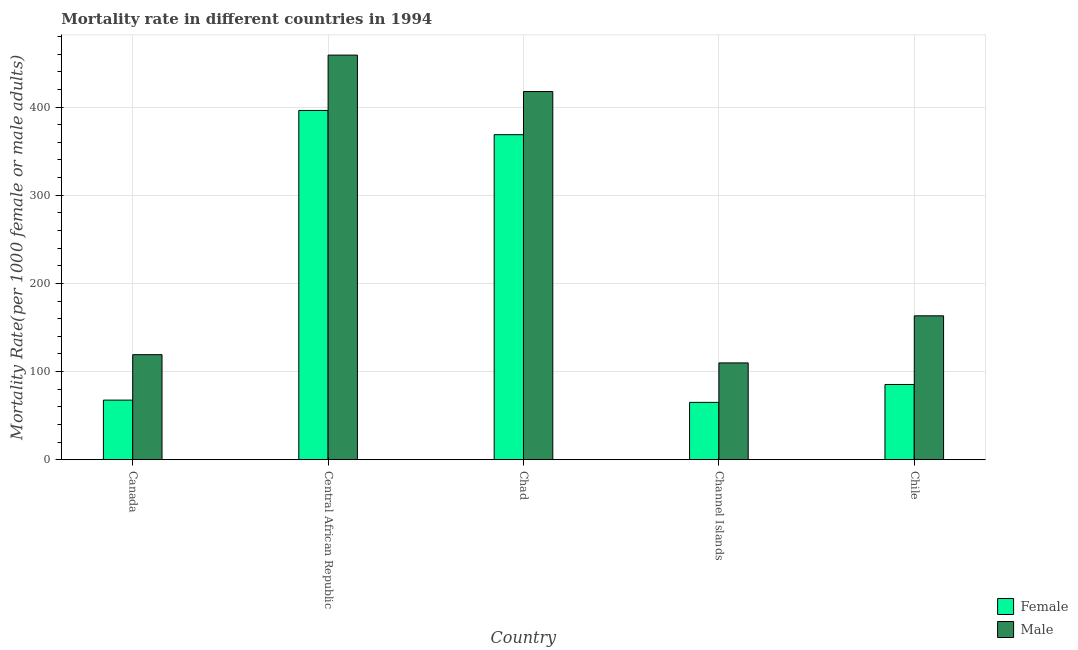How many different coloured bars are there?
Your answer should be compact. 2. Are the number of bars per tick equal to the number of legend labels?
Make the answer very short. Yes. How many bars are there on the 3rd tick from the left?
Provide a short and direct response. 2. What is the label of the 4th group of bars from the left?
Keep it short and to the point. Channel Islands. What is the male mortality rate in Chile?
Your response must be concise. 163.22. Across all countries, what is the maximum female mortality rate?
Your response must be concise. 396.2. Across all countries, what is the minimum female mortality rate?
Your response must be concise. 65.03. In which country was the female mortality rate maximum?
Make the answer very short. Central African Republic. In which country was the male mortality rate minimum?
Ensure brevity in your answer.  Channel Islands. What is the total male mortality rate in the graph?
Keep it short and to the point. 1268.75. What is the difference between the female mortality rate in Chad and that in Chile?
Your answer should be very brief. 283.38. What is the difference between the male mortality rate in Chad and the female mortality rate in Central African Republic?
Make the answer very short. 21.44. What is the average male mortality rate per country?
Offer a very short reply. 253.75. What is the difference between the female mortality rate and male mortality rate in Chad?
Keep it short and to the point. -48.94. In how many countries, is the female mortality rate greater than 100 ?
Offer a terse response. 2. What is the ratio of the male mortality rate in Central African Republic to that in Chad?
Provide a short and direct response. 1.1. Is the difference between the male mortality rate in Central African Republic and Chile greater than the difference between the female mortality rate in Central African Republic and Chile?
Your answer should be compact. No. What is the difference between the highest and the second highest female mortality rate?
Give a very brief answer. 27.5. What is the difference between the highest and the lowest male mortality rate?
Ensure brevity in your answer.  349.18. What does the 1st bar from the right in Chad represents?
Offer a terse response. Male. Are all the bars in the graph horizontal?
Provide a succinct answer. No. How many countries are there in the graph?
Offer a very short reply. 5. Are the values on the major ticks of Y-axis written in scientific E-notation?
Ensure brevity in your answer.  No. Does the graph contain any zero values?
Your answer should be very brief. No. Does the graph contain grids?
Ensure brevity in your answer.  Yes. How are the legend labels stacked?
Your response must be concise. Vertical. What is the title of the graph?
Keep it short and to the point. Mortality rate in different countries in 1994. What is the label or title of the X-axis?
Give a very brief answer. Country. What is the label or title of the Y-axis?
Provide a short and direct response. Mortality Rate(per 1000 female or male adults). What is the Mortality Rate(per 1000 female or male adults) in Female in Canada?
Give a very brief answer. 67.58. What is the Mortality Rate(per 1000 female or male adults) in Male in Canada?
Make the answer very short. 119.14. What is the Mortality Rate(per 1000 female or male adults) of Female in Central African Republic?
Provide a short and direct response. 396.2. What is the Mortality Rate(per 1000 female or male adults) of Male in Central African Republic?
Ensure brevity in your answer.  458.97. What is the Mortality Rate(per 1000 female or male adults) in Female in Chad?
Give a very brief answer. 368.69. What is the Mortality Rate(per 1000 female or male adults) of Male in Chad?
Provide a short and direct response. 417.63. What is the Mortality Rate(per 1000 female or male adults) in Female in Channel Islands?
Your answer should be very brief. 65.03. What is the Mortality Rate(per 1000 female or male adults) of Male in Channel Islands?
Make the answer very short. 109.79. What is the Mortality Rate(per 1000 female or male adults) of Female in Chile?
Provide a short and direct response. 85.31. What is the Mortality Rate(per 1000 female or male adults) in Male in Chile?
Give a very brief answer. 163.22. Across all countries, what is the maximum Mortality Rate(per 1000 female or male adults) in Female?
Your answer should be compact. 396.2. Across all countries, what is the maximum Mortality Rate(per 1000 female or male adults) in Male?
Give a very brief answer. 458.97. Across all countries, what is the minimum Mortality Rate(per 1000 female or male adults) in Female?
Offer a very short reply. 65.03. Across all countries, what is the minimum Mortality Rate(per 1000 female or male adults) in Male?
Ensure brevity in your answer.  109.79. What is the total Mortality Rate(per 1000 female or male adults) in Female in the graph?
Make the answer very short. 982.81. What is the total Mortality Rate(per 1000 female or male adults) in Male in the graph?
Your response must be concise. 1268.75. What is the difference between the Mortality Rate(per 1000 female or male adults) of Female in Canada and that in Central African Republic?
Make the answer very short. -328.61. What is the difference between the Mortality Rate(per 1000 female or male adults) in Male in Canada and that in Central African Republic?
Your answer should be very brief. -339.83. What is the difference between the Mortality Rate(per 1000 female or male adults) of Female in Canada and that in Chad?
Make the answer very short. -301.11. What is the difference between the Mortality Rate(per 1000 female or male adults) in Male in Canada and that in Chad?
Make the answer very short. -298.49. What is the difference between the Mortality Rate(per 1000 female or male adults) in Female in Canada and that in Channel Islands?
Give a very brief answer. 2.56. What is the difference between the Mortality Rate(per 1000 female or male adults) in Male in Canada and that in Channel Islands?
Your answer should be very brief. 9.35. What is the difference between the Mortality Rate(per 1000 female or male adults) of Female in Canada and that in Chile?
Make the answer very short. -17.73. What is the difference between the Mortality Rate(per 1000 female or male adults) of Male in Canada and that in Chile?
Give a very brief answer. -44.08. What is the difference between the Mortality Rate(per 1000 female or male adults) of Female in Central African Republic and that in Chad?
Your response must be concise. 27.5. What is the difference between the Mortality Rate(per 1000 female or male adults) of Male in Central African Republic and that in Chad?
Keep it short and to the point. 41.34. What is the difference between the Mortality Rate(per 1000 female or male adults) of Female in Central African Republic and that in Channel Islands?
Provide a succinct answer. 331.17. What is the difference between the Mortality Rate(per 1000 female or male adults) in Male in Central African Republic and that in Channel Islands?
Ensure brevity in your answer.  349.19. What is the difference between the Mortality Rate(per 1000 female or male adults) of Female in Central African Republic and that in Chile?
Your answer should be very brief. 310.88. What is the difference between the Mortality Rate(per 1000 female or male adults) of Male in Central African Republic and that in Chile?
Provide a succinct answer. 295.76. What is the difference between the Mortality Rate(per 1000 female or male adults) of Female in Chad and that in Channel Islands?
Make the answer very short. 303.67. What is the difference between the Mortality Rate(per 1000 female or male adults) of Male in Chad and that in Channel Islands?
Provide a short and direct response. 307.85. What is the difference between the Mortality Rate(per 1000 female or male adults) of Female in Chad and that in Chile?
Offer a terse response. 283.38. What is the difference between the Mortality Rate(per 1000 female or male adults) in Male in Chad and that in Chile?
Ensure brevity in your answer.  254.42. What is the difference between the Mortality Rate(per 1000 female or male adults) of Female in Channel Islands and that in Chile?
Give a very brief answer. -20.29. What is the difference between the Mortality Rate(per 1000 female or male adults) in Male in Channel Islands and that in Chile?
Your response must be concise. -53.43. What is the difference between the Mortality Rate(per 1000 female or male adults) in Female in Canada and the Mortality Rate(per 1000 female or male adults) in Male in Central African Republic?
Provide a succinct answer. -391.39. What is the difference between the Mortality Rate(per 1000 female or male adults) of Female in Canada and the Mortality Rate(per 1000 female or male adults) of Male in Chad?
Offer a very short reply. -350.05. What is the difference between the Mortality Rate(per 1000 female or male adults) in Female in Canada and the Mortality Rate(per 1000 female or male adults) in Male in Channel Islands?
Make the answer very short. -42.2. What is the difference between the Mortality Rate(per 1000 female or male adults) in Female in Canada and the Mortality Rate(per 1000 female or male adults) in Male in Chile?
Your response must be concise. -95.63. What is the difference between the Mortality Rate(per 1000 female or male adults) in Female in Central African Republic and the Mortality Rate(per 1000 female or male adults) in Male in Chad?
Your answer should be very brief. -21.44. What is the difference between the Mortality Rate(per 1000 female or male adults) in Female in Central African Republic and the Mortality Rate(per 1000 female or male adults) in Male in Channel Islands?
Your response must be concise. 286.41. What is the difference between the Mortality Rate(per 1000 female or male adults) of Female in Central African Republic and the Mortality Rate(per 1000 female or male adults) of Male in Chile?
Your response must be concise. 232.98. What is the difference between the Mortality Rate(per 1000 female or male adults) in Female in Chad and the Mortality Rate(per 1000 female or male adults) in Male in Channel Islands?
Ensure brevity in your answer.  258.91. What is the difference between the Mortality Rate(per 1000 female or male adults) in Female in Chad and the Mortality Rate(per 1000 female or male adults) in Male in Chile?
Provide a short and direct response. 205.48. What is the difference between the Mortality Rate(per 1000 female or male adults) in Female in Channel Islands and the Mortality Rate(per 1000 female or male adults) in Male in Chile?
Provide a short and direct response. -98.19. What is the average Mortality Rate(per 1000 female or male adults) in Female per country?
Offer a terse response. 196.56. What is the average Mortality Rate(per 1000 female or male adults) of Male per country?
Your answer should be compact. 253.75. What is the difference between the Mortality Rate(per 1000 female or male adults) of Female and Mortality Rate(per 1000 female or male adults) of Male in Canada?
Make the answer very short. -51.56. What is the difference between the Mortality Rate(per 1000 female or male adults) in Female and Mortality Rate(per 1000 female or male adults) in Male in Central African Republic?
Your answer should be very brief. -62.78. What is the difference between the Mortality Rate(per 1000 female or male adults) in Female and Mortality Rate(per 1000 female or male adults) in Male in Chad?
Offer a very short reply. -48.94. What is the difference between the Mortality Rate(per 1000 female or male adults) in Female and Mortality Rate(per 1000 female or male adults) in Male in Channel Islands?
Provide a succinct answer. -44.76. What is the difference between the Mortality Rate(per 1000 female or male adults) in Female and Mortality Rate(per 1000 female or male adults) in Male in Chile?
Provide a short and direct response. -77.9. What is the ratio of the Mortality Rate(per 1000 female or male adults) of Female in Canada to that in Central African Republic?
Your response must be concise. 0.17. What is the ratio of the Mortality Rate(per 1000 female or male adults) in Male in Canada to that in Central African Republic?
Offer a very short reply. 0.26. What is the ratio of the Mortality Rate(per 1000 female or male adults) in Female in Canada to that in Chad?
Offer a terse response. 0.18. What is the ratio of the Mortality Rate(per 1000 female or male adults) of Male in Canada to that in Chad?
Make the answer very short. 0.29. What is the ratio of the Mortality Rate(per 1000 female or male adults) in Female in Canada to that in Channel Islands?
Make the answer very short. 1.04. What is the ratio of the Mortality Rate(per 1000 female or male adults) in Male in Canada to that in Channel Islands?
Offer a very short reply. 1.09. What is the ratio of the Mortality Rate(per 1000 female or male adults) in Female in Canada to that in Chile?
Offer a terse response. 0.79. What is the ratio of the Mortality Rate(per 1000 female or male adults) of Male in Canada to that in Chile?
Offer a very short reply. 0.73. What is the ratio of the Mortality Rate(per 1000 female or male adults) of Female in Central African Republic to that in Chad?
Provide a short and direct response. 1.07. What is the ratio of the Mortality Rate(per 1000 female or male adults) in Male in Central African Republic to that in Chad?
Your response must be concise. 1.1. What is the ratio of the Mortality Rate(per 1000 female or male adults) in Female in Central African Republic to that in Channel Islands?
Keep it short and to the point. 6.09. What is the ratio of the Mortality Rate(per 1000 female or male adults) in Male in Central African Republic to that in Channel Islands?
Your answer should be very brief. 4.18. What is the ratio of the Mortality Rate(per 1000 female or male adults) of Female in Central African Republic to that in Chile?
Provide a short and direct response. 4.64. What is the ratio of the Mortality Rate(per 1000 female or male adults) in Male in Central African Republic to that in Chile?
Provide a short and direct response. 2.81. What is the ratio of the Mortality Rate(per 1000 female or male adults) in Female in Chad to that in Channel Islands?
Your answer should be very brief. 5.67. What is the ratio of the Mortality Rate(per 1000 female or male adults) in Male in Chad to that in Channel Islands?
Offer a very short reply. 3.8. What is the ratio of the Mortality Rate(per 1000 female or male adults) in Female in Chad to that in Chile?
Provide a short and direct response. 4.32. What is the ratio of the Mortality Rate(per 1000 female or male adults) in Male in Chad to that in Chile?
Your response must be concise. 2.56. What is the ratio of the Mortality Rate(per 1000 female or male adults) of Female in Channel Islands to that in Chile?
Your answer should be very brief. 0.76. What is the ratio of the Mortality Rate(per 1000 female or male adults) in Male in Channel Islands to that in Chile?
Your answer should be compact. 0.67. What is the difference between the highest and the second highest Mortality Rate(per 1000 female or male adults) in Female?
Offer a very short reply. 27.5. What is the difference between the highest and the second highest Mortality Rate(per 1000 female or male adults) of Male?
Your answer should be very brief. 41.34. What is the difference between the highest and the lowest Mortality Rate(per 1000 female or male adults) in Female?
Make the answer very short. 331.17. What is the difference between the highest and the lowest Mortality Rate(per 1000 female or male adults) of Male?
Offer a very short reply. 349.19. 